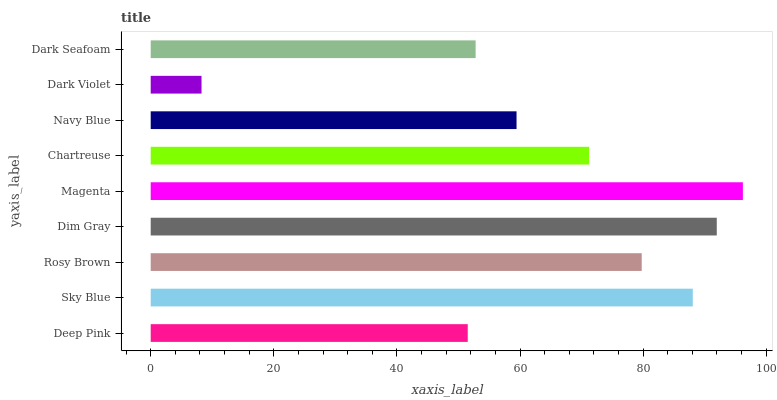Is Dark Violet the minimum?
Answer yes or no. Yes. Is Magenta the maximum?
Answer yes or no. Yes. Is Sky Blue the minimum?
Answer yes or no. No. Is Sky Blue the maximum?
Answer yes or no. No. Is Sky Blue greater than Deep Pink?
Answer yes or no. Yes. Is Deep Pink less than Sky Blue?
Answer yes or no. Yes. Is Deep Pink greater than Sky Blue?
Answer yes or no. No. Is Sky Blue less than Deep Pink?
Answer yes or no. No. Is Chartreuse the high median?
Answer yes or no. Yes. Is Chartreuse the low median?
Answer yes or no. Yes. Is Dim Gray the high median?
Answer yes or no. No. Is Sky Blue the low median?
Answer yes or no. No. 